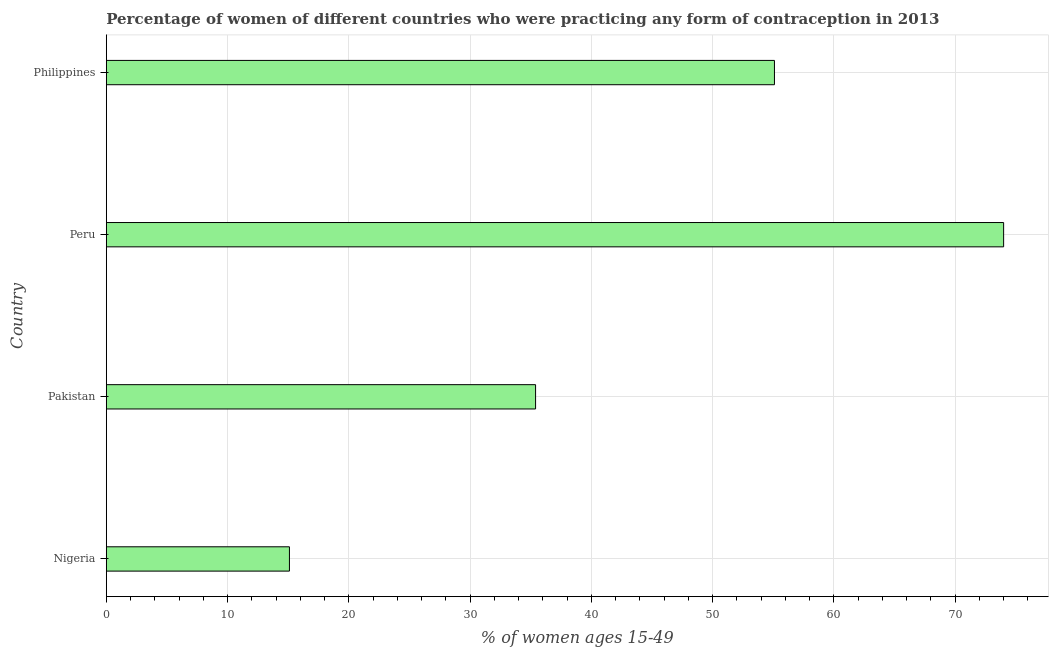Does the graph contain grids?
Your answer should be compact. Yes. What is the title of the graph?
Offer a very short reply. Percentage of women of different countries who were practicing any form of contraception in 2013. What is the label or title of the X-axis?
Provide a succinct answer. % of women ages 15-49. What is the contraceptive prevalence in Philippines?
Your answer should be very brief. 55.1. In which country was the contraceptive prevalence minimum?
Ensure brevity in your answer.  Nigeria. What is the sum of the contraceptive prevalence?
Keep it short and to the point. 179.6. What is the average contraceptive prevalence per country?
Provide a succinct answer. 44.9. What is the median contraceptive prevalence?
Make the answer very short. 45.25. What is the ratio of the contraceptive prevalence in Pakistan to that in Philippines?
Give a very brief answer. 0.64. Is the contraceptive prevalence in Peru less than that in Philippines?
Provide a short and direct response. No. Is the difference between the contraceptive prevalence in Nigeria and Pakistan greater than the difference between any two countries?
Offer a very short reply. No. What is the difference between the highest and the lowest contraceptive prevalence?
Give a very brief answer. 58.9. In how many countries, is the contraceptive prevalence greater than the average contraceptive prevalence taken over all countries?
Make the answer very short. 2. How many bars are there?
Provide a succinct answer. 4. Are all the bars in the graph horizontal?
Offer a terse response. Yes. What is the difference between two consecutive major ticks on the X-axis?
Offer a very short reply. 10. What is the % of women ages 15-49 in Nigeria?
Keep it short and to the point. 15.1. What is the % of women ages 15-49 in Pakistan?
Keep it short and to the point. 35.4. What is the % of women ages 15-49 of Peru?
Your answer should be compact. 74. What is the % of women ages 15-49 of Philippines?
Provide a succinct answer. 55.1. What is the difference between the % of women ages 15-49 in Nigeria and Pakistan?
Your response must be concise. -20.3. What is the difference between the % of women ages 15-49 in Nigeria and Peru?
Offer a terse response. -58.9. What is the difference between the % of women ages 15-49 in Pakistan and Peru?
Your answer should be very brief. -38.6. What is the difference between the % of women ages 15-49 in Pakistan and Philippines?
Make the answer very short. -19.7. What is the difference between the % of women ages 15-49 in Peru and Philippines?
Your response must be concise. 18.9. What is the ratio of the % of women ages 15-49 in Nigeria to that in Pakistan?
Your answer should be very brief. 0.43. What is the ratio of the % of women ages 15-49 in Nigeria to that in Peru?
Provide a short and direct response. 0.2. What is the ratio of the % of women ages 15-49 in Nigeria to that in Philippines?
Offer a very short reply. 0.27. What is the ratio of the % of women ages 15-49 in Pakistan to that in Peru?
Ensure brevity in your answer.  0.48. What is the ratio of the % of women ages 15-49 in Pakistan to that in Philippines?
Your answer should be compact. 0.64. What is the ratio of the % of women ages 15-49 in Peru to that in Philippines?
Offer a very short reply. 1.34. 